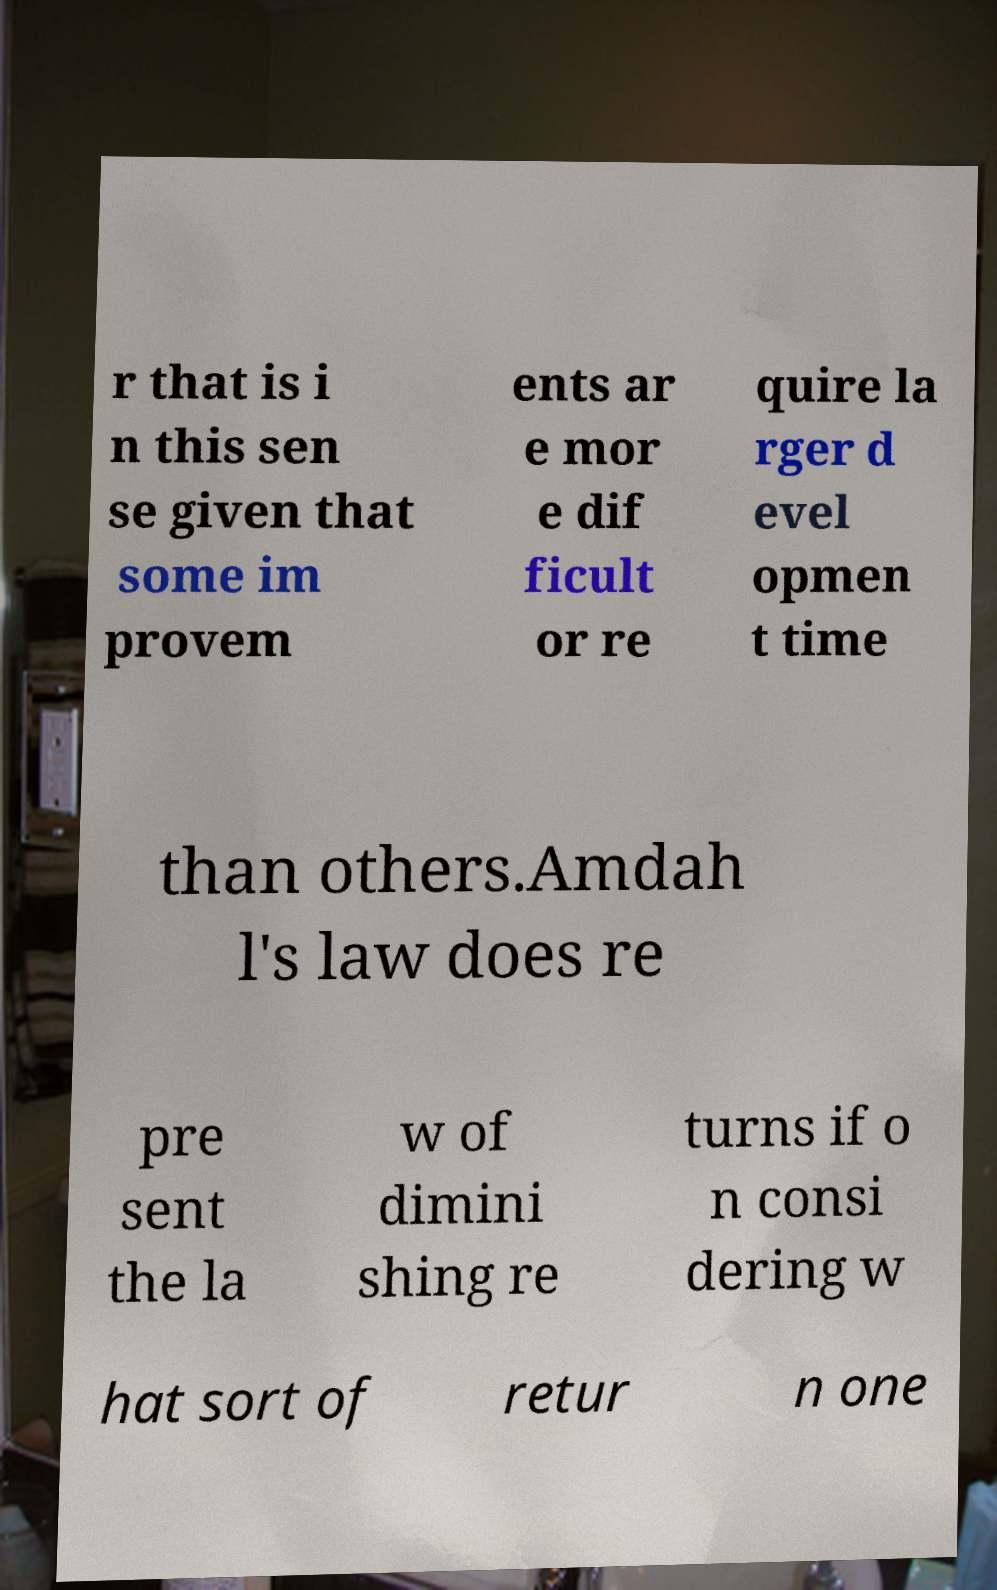Can you read and provide the text displayed in the image?This photo seems to have some interesting text. Can you extract and type it out for me? r that is i n this sen se given that some im provem ents ar e mor e dif ficult or re quire la rger d evel opmen t time than others.Amdah l's law does re pre sent the la w of dimini shing re turns if o n consi dering w hat sort of retur n one 